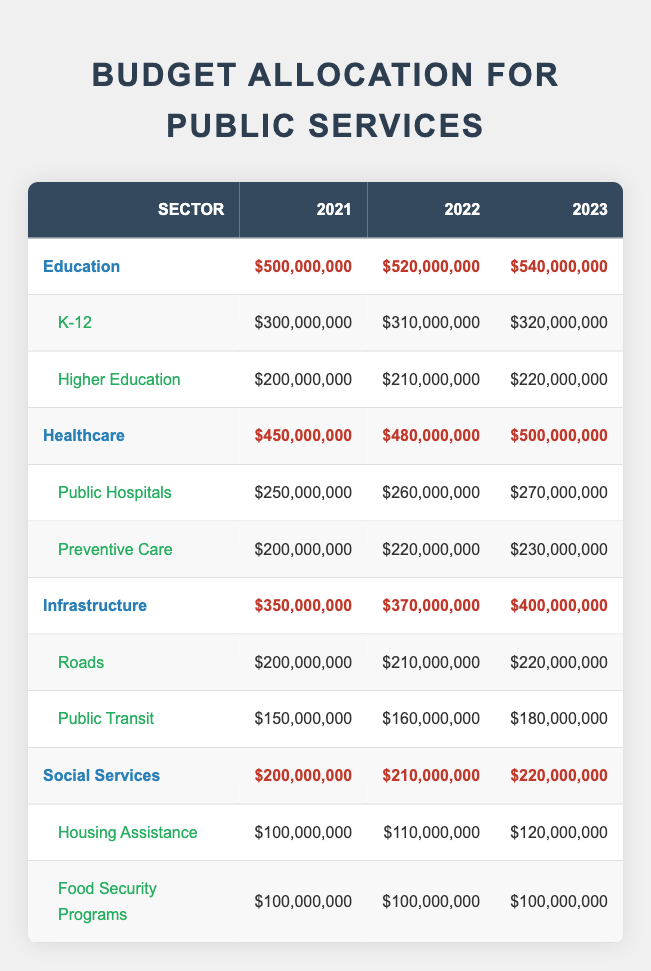What is the total budget for Education in 2022? The table shows the total budget for Education in 2022 as $520,000,000.
Answer: $520,000,000 How much did Public Hospitals receive in funding in 2021? The table lists Public Hospitals under Healthcare and shows their funding for 2021 as $250,000,000.
Answer: $250,000,000 Did the funding for Food Security Programs change from 2021 to 2023? By looking at the table, it shows Food Security Programs received $100,000,000 in both 2021 and 2023, indicating there was no change.
Answer: No Which sector received the highest total funding in 2023? Reviewing the sectors for 2023, Education received $540,000,000, Healthcare got $500,000,000, Infrastructure had $400,000,000, and Social Services received $220,000,000, making Education the highest.
Answer: Education What is the increase in budget allocation for Infrastructure from 2021 to 2023? The total budget for Infrastructure in 2021 was $350,000,000 and in 2023 it is $400,000,000. The increase can be calculated as $400,000,000 - $350,000,000 = $50,000,000.
Answer: $50,000,000 Was the budget for Higher Education greater than that of Housing Assistance in 2022? In 2022, the budget for Higher Education was $210,000,000 and Housing Assistance was $110,000,000. Since $210,000,000 is greater than $110,000,000, the answer is yes.
Answer: Yes What is the combined total funding for both K-12 and Higher Education in 2023? For 2023, K-12 received $320,000,000 and Higher Education received $220,000,000. The combined total is $320,000,000 + $220,000,000 = $540,000,000.
Answer: $540,000,000 In which year was the funding for Preventive Care the highest? By checking the values in the table, Preventive Care received $200,000,000 in 2021, $220,000,000 in 2022, and $230,000,000 in 2023. Therefore, the highest funding was in 2023.
Answer: 2023 Which sector consistently received the least amount of total funding from 2021 to 2023? Looking at the "Total" row for each sector from 2021 to 2023, Social Services had the lowest funding amounts: $200,000,000, $210,000,000, and $220,000,000. Hence, it consistently received the least.
Answer: Social Services 